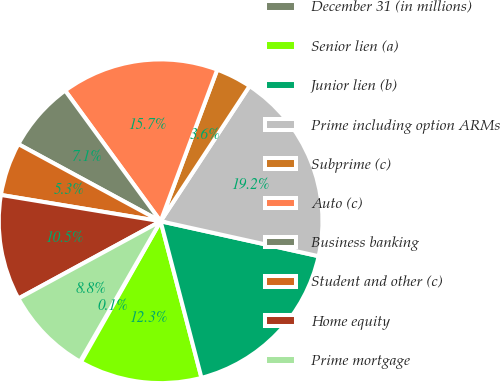<chart> <loc_0><loc_0><loc_500><loc_500><pie_chart><fcel>December 31 (in millions)<fcel>Senior lien (a)<fcel>Junior lien (b)<fcel>Prime including option ARMs<fcel>Subprime (c)<fcel>Auto (c)<fcel>Business banking<fcel>Student and other (c)<fcel>Home equity<fcel>Prime mortgage<nl><fcel>0.1%<fcel>12.26%<fcel>17.47%<fcel>19.2%<fcel>3.57%<fcel>15.73%<fcel>7.05%<fcel>5.31%<fcel>10.52%<fcel>8.78%<nl></chart> 